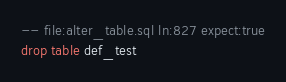<code> <loc_0><loc_0><loc_500><loc_500><_SQL_>-- file:alter_table.sql ln:827 expect:true
drop table def_test
</code> 